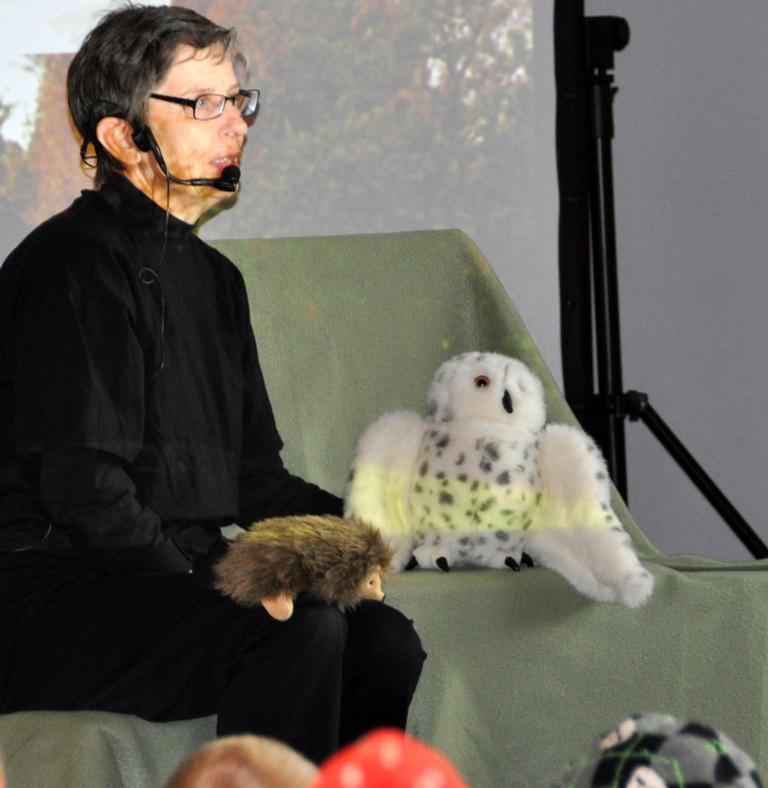Can you describe this image briefly? In this picture we can see a person with the microphone and the person is sitting on an object. On the right side of the person there are toys and a stand. Behind the person, it looks like a screen. 